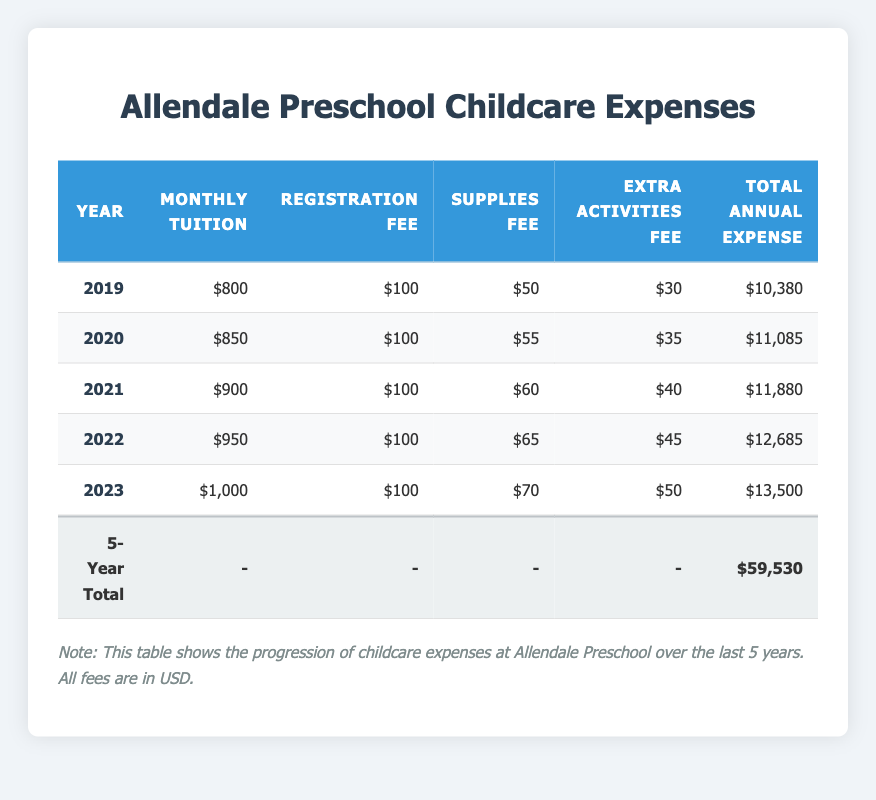What was the total annual expense for 2021? In the table, the total annual expense for the year 2021 is explicitly listed under the "Total Annual Expense" column. The expense for that year is $11,880.
Answer: 11,880 How much did the monthly tuition increase from 2019 to 2023? For 2019, the monthly tuition was $800, and for 2023, it is $1,000. To find the increase, subtract the earlier year from the later year: $1,000 - $800 = $200.
Answer: 200 Was there an increase in the supplies fee every year from 2019 to 2023? Reviewing the supplies fee column, we can see the following fees: 2019: $50, 2020: $55, 2021: $60, 2022: $65, and 2023: $70. Each subsequent year has a higher fees than the previous year, confirming the increase year over year.
Answer: Yes What is the average total annual expense over the 5 years? To find the average, first sum the total annual expenses: 10,380 + 11,085 + 11,880 + 12,685 + 13,500 = 59,530. Then divide this sum by the number of years (5): 59,530 / 5 = 11,906.
Answer: 11,906 What was the largest total annual expense in a single year? By examining the "Total Annual Expense" column for each year, we note: 
2019: $10,380
2020: $11,085
2021: $11,880
2022: $12,685
2023: $13,500
The largest among these is $13,500 for the year 2023.
Answer: 13,500 How much did the extra activities fee change from 2020 to 2022? The extra activities fee for 2020 is $35, and for 2022 it is $45. To find the change, subtract the earlier fee from the later fee: $45 - $35 = $10.
Answer: 10 In which year was the monthly tuition the lowest? By analyzing the monthly tuition column, the values are: 2019: $800, 2020: $850, 2021: $900, 2022: $950, 2023: $1,000. The lowest value is $800 in the year 2019.
Answer: 2019 Was the total annual expense for 2022 higher than that of 2021? The total annual expense for 2021 is $11,880, and for 2022 it is $12,685. Comparing these two values, $12,685 is greater than $11,880.
Answer: Yes 